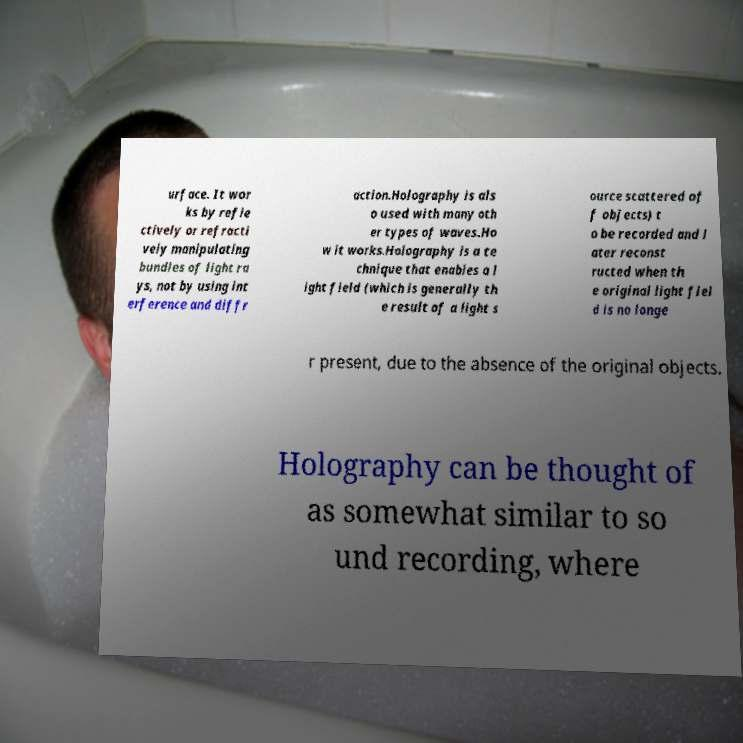Please identify and transcribe the text found in this image. urface. It wor ks by refle ctively or refracti vely manipulating bundles of light ra ys, not by using int erference and diffr action.Holography is als o used with many oth er types of waves.Ho w it works.Holography is a te chnique that enables a l ight field (which is generally th e result of a light s ource scattered of f objects) t o be recorded and l ater reconst ructed when th e original light fiel d is no longe r present, due to the absence of the original objects. Holography can be thought of as somewhat similar to so und recording, where 